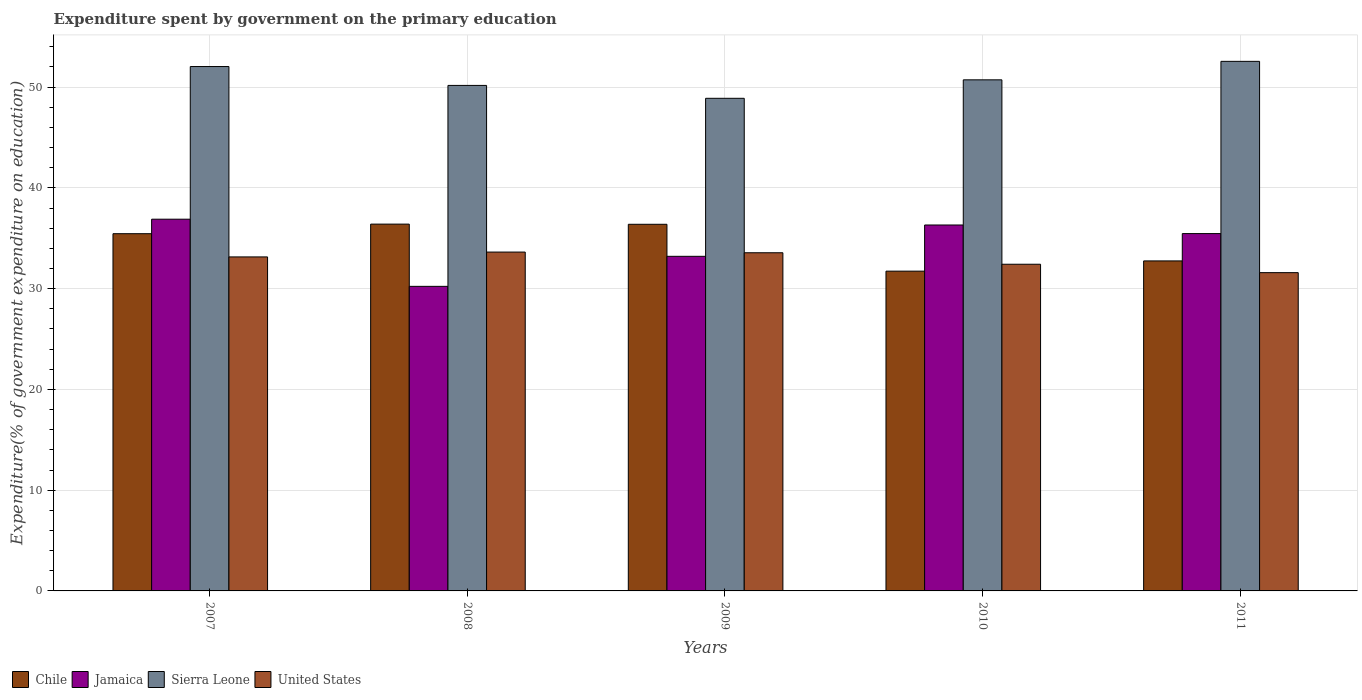Are the number of bars per tick equal to the number of legend labels?
Ensure brevity in your answer.  Yes. What is the label of the 2nd group of bars from the left?
Your response must be concise. 2008. In how many cases, is the number of bars for a given year not equal to the number of legend labels?
Make the answer very short. 0. What is the expenditure spent by government on the primary education in Jamaica in 2008?
Ensure brevity in your answer.  30.23. Across all years, what is the maximum expenditure spent by government on the primary education in Chile?
Make the answer very short. 36.4. Across all years, what is the minimum expenditure spent by government on the primary education in Chile?
Keep it short and to the point. 31.74. In which year was the expenditure spent by government on the primary education in United States maximum?
Provide a short and direct response. 2008. In which year was the expenditure spent by government on the primary education in Jamaica minimum?
Offer a terse response. 2008. What is the total expenditure spent by government on the primary education in Jamaica in the graph?
Make the answer very short. 172.11. What is the difference between the expenditure spent by government on the primary education in Chile in 2008 and that in 2011?
Keep it short and to the point. 3.65. What is the difference between the expenditure spent by government on the primary education in United States in 2011 and the expenditure spent by government on the primary education in Sierra Leone in 2007?
Offer a terse response. -20.46. What is the average expenditure spent by government on the primary education in Sierra Leone per year?
Your answer should be very brief. 50.88. In the year 2007, what is the difference between the expenditure spent by government on the primary education in United States and expenditure spent by government on the primary education in Chile?
Offer a terse response. -2.3. In how many years, is the expenditure spent by government on the primary education in Jamaica greater than 26 %?
Ensure brevity in your answer.  5. What is the ratio of the expenditure spent by government on the primary education in Chile in 2007 to that in 2010?
Make the answer very short. 1.12. What is the difference between the highest and the second highest expenditure spent by government on the primary education in United States?
Provide a succinct answer. 0.07. What is the difference between the highest and the lowest expenditure spent by government on the primary education in Sierra Leone?
Offer a very short reply. 3.67. Is the sum of the expenditure spent by government on the primary education in Sierra Leone in 2007 and 2010 greater than the maximum expenditure spent by government on the primary education in United States across all years?
Provide a short and direct response. Yes. Is it the case that in every year, the sum of the expenditure spent by government on the primary education in Sierra Leone and expenditure spent by government on the primary education in Jamaica is greater than the sum of expenditure spent by government on the primary education in United States and expenditure spent by government on the primary education in Chile?
Provide a succinct answer. Yes. What does the 3rd bar from the left in 2007 represents?
Your answer should be very brief. Sierra Leone. How many bars are there?
Keep it short and to the point. 20. Are all the bars in the graph horizontal?
Ensure brevity in your answer.  No. Are the values on the major ticks of Y-axis written in scientific E-notation?
Your answer should be very brief. No. Does the graph contain any zero values?
Make the answer very short. No. What is the title of the graph?
Ensure brevity in your answer.  Expenditure spent by government on the primary education. What is the label or title of the X-axis?
Offer a very short reply. Years. What is the label or title of the Y-axis?
Give a very brief answer. Expenditure(% of government expenditure on education). What is the Expenditure(% of government expenditure on education) of Chile in 2007?
Offer a terse response. 35.45. What is the Expenditure(% of government expenditure on education) of Jamaica in 2007?
Ensure brevity in your answer.  36.89. What is the Expenditure(% of government expenditure on education) of Sierra Leone in 2007?
Offer a terse response. 52.04. What is the Expenditure(% of government expenditure on education) of United States in 2007?
Offer a very short reply. 33.15. What is the Expenditure(% of government expenditure on education) in Chile in 2008?
Your response must be concise. 36.4. What is the Expenditure(% of government expenditure on education) in Jamaica in 2008?
Provide a succinct answer. 30.23. What is the Expenditure(% of government expenditure on education) in Sierra Leone in 2008?
Your answer should be compact. 50.17. What is the Expenditure(% of government expenditure on education) in United States in 2008?
Keep it short and to the point. 33.63. What is the Expenditure(% of government expenditure on education) in Chile in 2009?
Provide a short and direct response. 36.39. What is the Expenditure(% of government expenditure on education) of Jamaica in 2009?
Offer a very short reply. 33.21. What is the Expenditure(% of government expenditure on education) of Sierra Leone in 2009?
Give a very brief answer. 48.89. What is the Expenditure(% of government expenditure on education) of United States in 2009?
Make the answer very short. 33.56. What is the Expenditure(% of government expenditure on education) in Chile in 2010?
Your response must be concise. 31.74. What is the Expenditure(% of government expenditure on education) in Jamaica in 2010?
Provide a short and direct response. 36.32. What is the Expenditure(% of government expenditure on education) in Sierra Leone in 2010?
Offer a very short reply. 50.72. What is the Expenditure(% of government expenditure on education) in United States in 2010?
Your response must be concise. 32.42. What is the Expenditure(% of government expenditure on education) of Chile in 2011?
Ensure brevity in your answer.  32.75. What is the Expenditure(% of government expenditure on education) in Jamaica in 2011?
Keep it short and to the point. 35.46. What is the Expenditure(% of government expenditure on education) of Sierra Leone in 2011?
Provide a succinct answer. 52.56. What is the Expenditure(% of government expenditure on education) in United States in 2011?
Keep it short and to the point. 31.59. Across all years, what is the maximum Expenditure(% of government expenditure on education) in Chile?
Ensure brevity in your answer.  36.4. Across all years, what is the maximum Expenditure(% of government expenditure on education) in Jamaica?
Offer a very short reply. 36.89. Across all years, what is the maximum Expenditure(% of government expenditure on education) of Sierra Leone?
Provide a short and direct response. 52.56. Across all years, what is the maximum Expenditure(% of government expenditure on education) of United States?
Your answer should be compact. 33.63. Across all years, what is the minimum Expenditure(% of government expenditure on education) in Chile?
Your answer should be compact. 31.74. Across all years, what is the minimum Expenditure(% of government expenditure on education) of Jamaica?
Offer a very short reply. 30.23. Across all years, what is the minimum Expenditure(% of government expenditure on education) in Sierra Leone?
Your answer should be very brief. 48.89. Across all years, what is the minimum Expenditure(% of government expenditure on education) in United States?
Offer a terse response. 31.59. What is the total Expenditure(% of government expenditure on education) in Chile in the graph?
Provide a short and direct response. 172.73. What is the total Expenditure(% of government expenditure on education) in Jamaica in the graph?
Your response must be concise. 172.11. What is the total Expenditure(% of government expenditure on education) in Sierra Leone in the graph?
Keep it short and to the point. 254.38. What is the total Expenditure(% of government expenditure on education) in United States in the graph?
Offer a very short reply. 164.35. What is the difference between the Expenditure(% of government expenditure on education) in Chile in 2007 and that in 2008?
Give a very brief answer. -0.95. What is the difference between the Expenditure(% of government expenditure on education) in Jamaica in 2007 and that in 2008?
Your answer should be compact. 6.67. What is the difference between the Expenditure(% of government expenditure on education) of Sierra Leone in 2007 and that in 2008?
Give a very brief answer. 1.87. What is the difference between the Expenditure(% of government expenditure on education) in United States in 2007 and that in 2008?
Keep it short and to the point. -0.48. What is the difference between the Expenditure(% of government expenditure on education) in Chile in 2007 and that in 2009?
Your answer should be very brief. -0.93. What is the difference between the Expenditure(% of government expenditure on education) of Jamaica in 2007 and that in 2009?
Offer a very short reply. 3.69. What is the difference between the Expenditure(% of government expenditure on education) of Sierra Leone in 2007 and that in 2009?
Your response must be concise. 3.15. What is the difference between the Expenditure(% of government expenditure on education) in United States in 2007 and that in 2009?
Offer a very short reply. -0.41. What is the difference between the Expenditure(% of government expenditure on education) in Chile in 2007 and that in 2010?
Make the answer very short. 3.72. What is the difference between the Expenditure(% of government expenditure on education) in Jamaica in 2007 and that in 2010?
Your response must be concise. 0.58. What is the difference between the Expenditure(% of government expenditure on education) of Sierra Leone in 2007 and that in 2010?
Your answer should be compact. 1.32. What is the difference between the Expenditure(% of government expenditure on education) of United States in 2007 and that in 2010?
Provide a short and direct response. 0.73. What is the difference between the Expenditure(% of government expenditure on education) of Chile in 2007 and that in 2011?
Ensure brevity in your answer.  2.7. What is the difference between the Expenditure(% of government expenditure on education) in Jamaica in 2007 and that in 2011?
Make the answer very short. 1.43. What is the difference between the Expenditure(% of government expenditure on education) in Sierra Leone in 2007 and that in 2011?
Ensure brevity in your answer.  -0.51. What is the difference between the Expenditure(% of government expenditure on education) of United States in 2007 and that in 2011?
Your response must be concise. 1.56. What is the difference between the Expenditure(% of government expenditure on education) in Chile in 2008 and that in 2009?
Keep it short and to the point. 0.02. What is the difference between the Expenditure(% of government expenditure on education) in Jamaica in 2008 and that in 2009?
Give a very brief answer. -2.98. What is the difference between the Expenditure(% of government expenditure on education) in Sierra Leone in 2008 and that in 2009?
Provide a succinct answer. 1.28. What is the difference between the Expenditure(% of government expenditure on education) of United States in 2008 and that in 2009?
Ensure brevity in your answer.  0.07. What is the difference between the Expenditure(% of government expenditure on education) in Chile in 2008 and that in 2010?
Make the answer very short. 4.67. What is the difference between the Expenditure(% of government expenditure on education) of Jamaica in 2008 and that in 2010?
Provide a succinct answer. -6.09. What is the difference between the Expenditure(% of government expenditure on education) in Sierra Leone in 2008 and that in 2010?
Your answer should be compact. -0.55. What is the difference between the Expenditure(% of government expenditure on education) in United States in 2008 and that in 2010?
Offer a terse response. 1.21. What is the difference between the Expenditure(% of government expenditure on education) in Chile in 2008 and that in 2011?
Keep it short and to the point. 3.65. What is the difference between the Expenditure(% of government expenditure on education) of Jamaica in 2008 and that in 2011?
Your answer should be very brief. -5.24. What is the difference between the Expenditure(% of government expenditure on education) in Sierra Leone in 2008 and that in 2011?
Your answer should be compact. -2.39. What is the difference between the Expenditure(% of government expenditure on education) of United States in 2008 and that in 2011?
Your response must be concise. 2.04. What is the difference between the Expenditure(% of government expenditure on education) in Chile in 2009 and that in 2010?
Provide a succinct answer. 4.65. What is the difference between the Expenditure(% of government expenditure on education) in Jamaica in 2009 and that in 2010?
Your response must be concise. -3.11. What is the difference between the Expenditure(% of government expenditure on education) in Sierra Leone in 2009 and that in 2010?
Give a very brief answer. -1.83. What is the difference between the Expenditure(% of government expenditure on education) of United States in 2009 and that in 2010?
Offer a terse response. 1.14. What is the difference between the Expenditure(% of government expenditure on education) of Chile in 2009 and that in 2011?
Make the answer very short. 3.64. What is the difference between the Expenditure(% of government expenditure on education) in Jamaica in 2009 and that in 2011?
Offer a terse response. -2.26. What is the difference between the Expenditure(% of government expenditure on education) of Sierra Leone in 2009 and that in 2011?
Offer a terse response. -3.67. What is the difference between the Expenditure(% of government expenditure on education) of United States in 2009 and that in 2011?
Your response must be concise. 1.97. What is the difference between the Expenditure(% of government expenditure on education) of Chile in 2010 and that in 2011?
Provide a short and direct response. -1.02. What is the difference between the Expenditure(% of government expenditure on education) in Jamaica in 2010 and that in 2011?
Offer a very short reply. 0.85. What is the difference between the Expenditure(% of government expenditure on education) of Sierra Leone in 2010 and that in 2011?
Make the answer very short. -1.83. What is the difference between the Expenditure(% of government expenditure on education) of United States in 2010 and that in 2011?
Keep it short and to the point. 0.83. What is the difference between the Expenditure(% of government expenditure on education) in Chile in 2007 and the Expenditure(% of government expenditure on education) in Jamaica in 2008?
Your response must be concise. 5.23. What is the difference between the Expenditure(% of government expenditure on education) of Chile in 2007 and the Expenditure(% of government expenditure on education) of Sierra Leone in 2008?
Provide a short and direct response. -14.72. What is the difference between the Expenditure(% of government expenditure on education) in Chile in 2007 and the Expenditure(% of government expenditure on education) in United States in 2008?
Your answer should be very brief. 1.82. What is the difference between the Expenditure(% of government expenditure on education) in Jamaica in 2007 and the Expenditure(% of government expenditure on education) in Sierra Leone in 2008?
Give a very brief answer. -13.28. What is the difference between the Expenditure(% of government expenditure on education) in Jamaica in 2007 and the Expenditure(% of government expenditure on education) in United States in 2008?
Provide a succinct answer. 3.26. What is the difference between the Expenditure(% of government expenditure on education) of Sierra Leone in 2007 and the Expenditure(% of government expenditure on education) of United States in 2008?
Offer a terse response. 18.41. What is the difference between the Expenditure(% of government expenditure on education) in Chile in 2007 and the Expenditure(% of government expenditure on education) in Jamaica in 2009?
Your answer should be very brief. 2.25. What is the difference between the Expenditure(% of government expenditure on education) in Chile in 2007 and the Expenditure(% of government expenditure on education) in Sierra Leone in 2009?
Offer a very short reply. -13.44. What is the difference between the Expenditure(% of government expenditure on education) in Chile in 2007 and the Expenditure(% of government expenditure on education) in United States in 2009?
Offer a terse response. 1.89. What is the difference between the Expenditure(% of government expenditure on education) of Jamaica in 2007 and the Expenditure(% of government expenditure on education) of Sierra Leone in 2009?
Offer a terse response. -12. What is the difference between the Expenditure(% of government expenditure on education) in Jamaica in 2007 and the Expenditure(% of government expenditure on education) in United States in 2009?
Offer a very short reply. 3.33. What is the difference between the Expenditure(% of government expenditure on education) in Sierra Leone in 2007 and the Expenditure(% of government expenditure on education) in United States in 2009?
Offer a very short reply. 18.48. What is the difference between the Expenditure(% of government expenditure on education) of Chile in 2007 and the Expenditure(% of government expenditure on education) of Jamaica in 2010?
Give a very brief answer. -0.86. What is the difference between the Expenditure(% of government expenditure on education) in Chile in 2007 and the Expenditure(% of government expenditure on education) in Sierra Leone in 2010?
Make the answer very short. -15.27. What is the difference between the Expenditure(% of government expenditure on education) in Chile in 2007 and the Expenditure(% of government expenditure on education) in United States in 2010?
Give a very brief answer. 3.03. What is the difference between the Expenditure(% of government expenditure on education) of Jamaica in 2007 and the Expenditure(% of government expenditure on education) of Sierra Leone in 2010?
Give a very brief answer. -13.83. What is the difference between the Expenditure(% of government expenditure on education) in Jamaica in 2007 and the Expenditure(% of government expenditure on education) in United States in 2010?
Offer a very short reply. 4.47. What is the difference between the Expenditure(% of government expenditure on education) of Sierra Leone in 2007 and the Expenditure(% of government expenditure on education) of United States in 2010?
Offer a terse response. 19.62. What is the difference between the Expenditure(% of government expenditure on education) of Chile in 2007 and the Expenditure(% of government expenditure on education) of Jamaica in 2011?
Your answer should be compact. -0.01. What is the difference between the Expenditure(% of government expenditure on education) in Chile in 2007 and the Expenditure(% of government expenditure on education) in Sierra Leone in 2011?
Give a very brief answer. -17.1. What is the difference between the Expenditure(% of government expenditure on education) in Chile in 2007 and the Expenditure(% of government expenditure on education) in United States in 2011?
Your answer should be very brief. 3.87. What is the difference between the Expenditure(% of government expenditure on education) in Jamaica in 2007 and the Expenditure(% of government expenditure on education) in Sierra Leone in 2011?
Your answer should be compact. -15.66. What is the difference between the Expenditure(% of government expenditure on education) in Jamaica in 2007 and the Expenditure(% of government expenditure on education) in United States in 2011?
Ensure brevity in your answer.  5.3. What is the difference between the Expenditure(% of government expenditure on education) of Sierra Leone in 2007 and the Expenditure(% of government expenditure on education) of United States in 2011?
Your answer should be very brief. 20.46. What is the difference between the Expenditure(% of government expenditure on education) of Chile in 2008 and the Expenditure(% of government expenditure on education) of Jamaica in 2009?
Your answer should be compact. 3.2. What is the difference between the Expenditure(% of government expenditure on education) in Chile in 2008 and the Expenditure(% of government expenditure on education) in Sierra Leone in 2009?
Your answer should be very brief. -12.49. What is the difference between the Expenditure(% of government expenditure on education) in Chile in 2008 and the Expenditure(% of government expenditure on education) in United States in 2009?
Your answer should be compact. 2.84. What is the difference between the Expenditure(% of government expenditure on education) of Jamaica in 2008 and the Expenditure(% of government expenditure on education) of Sierra Leone in 2009?
Your answer should be compact. -18.66. What is the difference between the Expenditure(% of government expenditure on education) of Jamaica in 2008 and the Expenditure(% of government expenditure on education) of United States in 2009?
Make the answer very short. -3.33. What is the difference between the Expenditure(% of government expenditure on education) of Sierra Leone in 2008 and the Expenditure(% of government expenditure on education) of United States in 2009?
Make the answer very short. 16.61. What is the difference between the Expenditure(% of government expenditure on education) in Chile in 2008 and the Expenditure(% of government expenditure on education) in Jamaica in 2010?
Keep it short and to the point. 0.09. What is the difference between the Expenditure(% of government expenditure on education) of Chile in 2008 and the Expenditure(% of government expenditure on education) of Sierra Leone in 2010?
Give a very brief answer. -14.32. What is the difference between the Expenditure(% of government expenditure on education) in Chile in 2008 and the Expenditure(% of government expenditure on education) in United States in 2010?
Your answer should be very brief. 3.98. What is the difference between the Expenditure(% of government expenditure on education) of Jamaica in 2008 and the Expenditure(% of government expenditure on education) of Sierra Leone in 2010?
Make the answer very short. -20.5. What is the difference between the Expenditure(% of government expenditure on education) in Jamaica in 2008 and the Expenditure(% of government expenditure on education) in United States in 2010?
Offer a terse response. -2.19. What is the difference between the Expenditure(% of government expenditure on education) in Sierra Leone in 2008 and the Expenditure(% of government expenditure on education) in United States in 2010?
Provide a short and direct response. 17.75. What is the difference between the Expenditure(% of government expenditure on education) in Chile in 2008 and the Expenditure(% of government expenditure on education) in Jamaica in 2011?
Offer a terse response. 0.94. What is the difference between the Expenditure(% of government expenditure on education) of Chile in 2008 and the Expenditure(% of government expenditure on education) of Sierra Leone in 2011?
Keep it short and to the point. -16.15. What is the difference between the Expenditure(% of government expenditure on education) in Chile in 2008 and the Expenditure(% of government expenditure on education) in United States in 2011?
Provide a short and direct response. 4.82. What is the difference between the Expenditure(% of government expenditure on education) of Jamaica in 2008 and the Expenditure(% of government expenditure on education) of Sierra Leone in 2011?
Offer a very short reply. -22.33. What is the difference between the Expenditure(% of government expenditure on education) in Jamaica in 2008 and the Expenditure(% of government expenditure on education) in United States in 2011?
Give a very brief answer. -1.36. What is the difference between the Expenditure(% of government expenditure on education) in Sierra Leone in 2008 and the Expenditure(% of government expenditure on education) in United States in 2011?
Make the answer very short. 18.58. What is the difference between the Expenditure(% of government expenditure on education) of Chile in 2009 and the Expenditure(% of government expenditure on education) of Jamaica in 2010?
Provide a short and direct response. 0.07. What is the difference between the Expenditure(% of government expenditure on education) of Chile in 2009 and the Expenditure(% of government expenditure on education) of Sierra Leone in 2010?
Provide a short and direct response. -14.34. What is the difference between the Expenditure(% of government expenditure on education) in Chile in 2009 and the Expenditure(% of government expenditure on education) in United States in 2010?
Provide a succinct answer. 3.97. What is the difference between the Expenditure(% of government expenditure on education) in Jamaica in 2009 and the Expenditure(% of government expenditure on education) in Sierra Leone in 2010?
Provide a short and direct response. -17.52. What is the difference between the Expenditure(% of government expenditure on education) in Jamaica in 2009 and the Expenditure(% of government expenditure on education) in United States in 2010?
Make the answer very short. 0.79. What is the difference between the Expenditure(% of government expenditure on education) in Sierra Leone in 2009 and the Expenditure(% of government expenditure on education) in United States in 2010?
Offer a terse response. 16.47. What is the difference between the Expenditure(% of government expenditure on education) of Chile in 2009 and the Expenditure(% of government expenditure on education) of Jamaica in 2011?
Your response must be concise. 0.92. What is the difference between the Expenditure(% of government expenditure on education) of Chile in 2009 and the Expenditure(% of government expenditure on education) of Sierra Leone in 2011?
Provide a short and direct response. -16.17. What is the difference between the Expenditure(% of government expenditure on education) of Chile in 2009 and the Expenditure(% of government expenditure on education) of United States in 2011?
Your answer should be very brief. 4.8. What is the difference between the Expenditure(% of government expenditure on education) in Jamaica in 2009 and the Expenditure(% of government expenditure on education) in Sierra Leone in 2011?
Keep it short and to the point. -19.35. What is the difference between the Expenditure(% of government expenditure on education) in Jamaica in 2009 and the Expenditure(% of government expenditure on education) in United States in 2011?
Provide a short and direct response. 1.62. What is the difference between the Expenditure(% of government expenditure on education) in Sierra Leone in 2009 and the Expenditure(% of government expenditure on education) in United States in 2011?
Give a very brief answer. 17.3. What is the difference between the Expenditure(% of government expenditure on education) in Chile in 2010 and the Expenditure(% of government expenditure on education) in Jamaica in 2011?
Your answer should be compact. -3.73. What is the difference between the Expenditure(% of government expenditure on education) in Chile in 2010 and the Expenditure(% of government expenditure on education) in Sierra Leone in 2011?
Offer a terse response. -20.82. What is the difference between the Expenditure(% of government expenditure on education) of Chile in 2010 and the Expenditure(% of government expenditure on education) of United States in 2011?
Make the answer very short. 0.15. What is the difference between the Expenditure(% of government expenditure on education) of Jamaica in 2010 and the Expenditure(% of government expenditure on education) of Sierra Leone in 2011?
Your answer should be very brief. -16.24. What is the difference between the Expenditure(% of government expenditure on education) in Jamaica in 2010 and the Expenditure(% of government expenditure on education) in United States in 2011?
Your answer should be compact. 4.73. What is the difference between the Expenditure(% of government expenditure on education) of Sierra Leone in 2010 and the Expenditure(% of government expenditure on education) of United States in 2011?
Keep it short and to the point. 19.14. What is the average Expenditure(% of government expenditure on education) in Chile per year?
Provide a succinct answer. 34.55. What is the average Expenditure(% of government expenditure on education) of Jamaica per year?
Keep it short and to the point. 34.42. What is the average Expenditure(% of government expenditure on education) in Sierra Leone per year?
Give a very brief answer. 50.88. What is the average Expenditure(% of government expenditure on education) of United States per year?
Make the answer very short. 32.87. In the year 2007, what is the difference between the Expenditure(% of government expenditure on education) in Chile and Expenditure(% of government expenditure on education) in Jamaica?
Provide a short and direct response. -1.44. In the year 2007, what is the difference between the Expenditure(% of government expenditure on education) in Chile and Expenditure(% of government expenditure on education) in Sierra Leone?
Offer a very short reply. -16.59. In the year 2007, what is the difference between the Expenditure(% of government expenditure on education) in Chile and Expenditure(% of government expenditure on education) in United States?
Offer a terse response. 2.31. In the year 2007, what is the difference between the Expenditure(% of government expenditure on education) in Jamaica and Expenditure(% of government expenditure on education) in Sierra Leone?
Provide a short and direct response. -15.15. In the year 2007, what is the difference between the Expenditure(% of government expenditure on education) of Jamaica and Expenditure(% of government expenditure on education) of United States?
Give a very brief answer. 3.74. In the year 2007, what is the difference between the Expenditure(% of government expenditure on education) in Sierra Leone and Expenditure(% of government expenditure on education) in United States?
Provide a succinct answer. 18.89. In the year 2008, what is the difference between the Expenditure(% of government expenditure on education) in Chile and Expenditure(% of government expenditure on education) in Jamaica?
Ensure brevity in your answer.  6.18. In the year 2008, what is the difference between the Expenditure(% of government expenditure on education) in Chile and Expenditure(% of government expenditure on education) in Sierra Leone?
Provide a succinct answer. -13.76. In the year 2008, what is the difference between the Expenditure(% of government expenditure on education) of Chile and Expenditure(% of government expenditure on education) of United States?
Give a very brief answer. 2.78. In the year 2008, what is the difference between the Expenditure(% of government expenditure on education) of Jamaica and Expenditure(% of government expenditure on education) of Sierra Leone?
Your response must be concise. -19.94. In the year 2008, what is the difference between the Expenditure(% of government expenditure on education) in Jamaica and Expenditure(% of government expenditure on education) in United States?
Ensure brevity in your answer.  -3.4. In the year 2008, what is the difference between the Expenditure(% of government expenditure on education) in Sierra Leone and Expenditure(% of government expenditure on education) in United States?
Ensure brevity in your answer.  16.54. In the year 2009, what is the difference between the Expenditure(% of government expenditure on education) in Chile and Expenditure(% of government expenditure on education) in Jamaica?
Your answer should be very brief. 3.18. In the year 2009, what is the difference between the Expenditure(% of government expenditure on education) of Chile and Expenditure(% of government expenditure on education) of Sierra Leone?
Ensure brevity in your answer.  -12.5. In the year 2009, what is the difference between the Expenditure(% of government expenditure on education) of Chile and Expenditure(% of government expenditure on education) of United States?
Make the answer very short. 2.83. In the year 2009, what is the difference between the Expenditure(% of government expenditure on education) of Jamaica and Expenditure(% of government expenditure on education) of Sierra Leone?
Your answer should be compact. -15.68. In the year 2009, what is the difference between the Expenditure(% of government expenditure on education) of Jamaica and Expenditure(% of government expenditure on education) of United States?
Your answer should be very brief. -0.35. In the year 2009, what is the difference between the Expenditure(% of government expenditure on education) of Sierra Leone and Expenditure(% of government expenditure on education) of United States?
Give a very brief answer. 15.33. In the year 2010, what is the difference between the Expenditure(% of government expenditure on education) of Chile and Expenditure(% of government expenditure on education) of Jamaica?
Your answer should be very brief. -4.58. In the year 2010, what is the difference between the Expenditure(% of government expenditure on education) of Chile and Expenditure(% of government expenditure on education) of Sierra Leone?
Make the answer very short. -18.99. In the year 2010, what is the difference between the Expenditure(% of government expenditure on education) in Chile and Expenditure(% of government expenditure on education) in United States?
Offer a very short reply. -0.69. In the year 2010, what is the difference between the Expenditure(% of government expenditure on education) of Jamaica and Expenditure(% of government expenditure on education) of Sierra Leone?
Ensure brevity in your answer.  -14.41. In the year 2010, what is the difference between the Expenditure(% of government expenditure on education) of Jamaica and Expenditure(% of government expenditure on education) of United States?
Provide a succinct answer. 3.9. In the year 2010, what is the difference between the Expenditure(% of government expenditure on education) of Sierra Leone and Expenditure(% of government expenditure on education) of United States?
Your answer should be very brief. 18.3. In the year 2011, what is the difference between the Expenditure(% of government expenditure on education) in Chile and Expenditure(% of government expenditure on education) in Jamaica?
Provide a short and direct response. -2.71. In the year 2011, what is the difference between the Expenditure(% of government expenditure on education) in Chile and Expenditure(% of government expenditure on education) in Sierra Leone?
Give a very brief answer. -19.81. In the year 2011, what is the difference between the Expenditure(% of government expenditure on education) of Chile and Expenditure(% of government expenditure on education) of United States?
Make the answer very short. 1.16. In the year 2011, what is the difference between the Expenditure(% of government expenditure on education) in Jamaica and Expenditure(% of government expenditure on education) in Sierra Leone?
Give a very brief answer. -17.09. In the year 2011, what is the difference between the Expenditure(% of government expenditure on education) in Jamaica and Expenditure(% of government expenditure on education) in United States?
Provide a succinct answer. 3.88. In the year 2011, what is the difference between the Expenditure(% of government expenditure on education) in Sierra Leone and Expenditure(% of government expenditure on education) in United States?
Ensure brevity in your answer.  20.97. What is the ratio of the Expenditure(% of government expenditure on education) in Chile in 2007 to that in 2008?
Ensure brevity in your answer.  0.97. What is the ratio of the Expenditure(% of government expenditure on education) in Jamaica in 2007 to that in 2008?
Make the answer very short. 1.22. What is the ratio of the Expenditure(% of government expenditure on education) of Sierra Leone in 2007 to that in 2008?
Offer a terse response. 1.04. What is the ratio of the Expenditure(% of government expenditure on education) in United States in 2007 to that in 2008?
Your answer should be very brief. 0.99. What is the ratio of the Expenditure(% of government expenditure on education) of Chile in 2007 to that in 2009?
Give a very brief answer. 0.97. What is the ratio of the Expenditure(% of government expenditure on education) of Jamaica in 2007 to that in 2009?
Make the answer very short. 1.11. What is the ratio of the Expenditure(% of government expenditure on education) of Sierra Leone in 2007 to that in 2009?
Offer a very short reply. 1.06. What is the ratio of the Expenditure(% of government expenditure on education) in United States in 2007 to that in 2009?
Ensure brevity in your answer.  0.99. What is the ratio of the Expenditure(% of government expenditure on education) in Chile in 2007 to that in 2010?
Your answer should be compact. 1.12. What is the ratio of the Expenditure(% of government expenditure on education) in Jamaica in 2007 to that in 2010?
Your answer should be compact. 1.02. What is the ratio of the Expenditure(% of government expenditure on education) in Sierra Leone in 2007 to that in 2010?
Give a very brief answer. 1.03. What is the ratio of the Expenditure(% of government expenditure on education) in United States in 2007 to that in 2010?
Provide a short and direct response. 1.02. What is the ratio of the Expenditure(% of government expenditure on education) in Chile in 2007 to that in 2011?
Your response must be concise. 1.08. What is the ratio of the Expenditure(% of government expenditure on education) in Jamaica in 2007 to that in 2011?
Your response must be concise. 1.04. What is the ratio of the Expenditure(% of government expenditure on education) in Sierra Leone in 2007 to that in 2011?
Offer a very short reply. 0.99. What is the ratio of the Expenditure(% of government expenditure on education) of United States in 2007 to that in 2011?
Ensure brevity in your answer.  1.05. What is the ratio of the Expenditure(% of government expenditure on education) of Chile in 2008 to that in 2009?
Your response must be concise. 1. What is the ratio of the Expenditure(% of government expenditure on education) in Jamaica in 2008 to that in 2009?
Your answer should be compact. 0.91. What is the ratio of the Expenditure(% of government expenditure on education) in Sierra Leone in 2008 to that in 2009?
Provide a short and direct response. 1.03. What is the ratio of the Expenditure(% of government expenditure on education) of Chile in 2008 to that in 2010?
Keep it short and to the point. 1.15. What is the ratio of the Expenditure(% of government expenditure on education) in Jamaica in 2008 to that in 2010?
Your answer should be very brief. 0.83. What is the ratio of the Expenditure(% of government expenditure on education) in Sierra Leone in 2008 to that in 2010?
Offer a very short reply. 0.99. What is the ratio of the Expenditure(% of government expenditure on education) of United States in 2008 to that in 2010?
Keep it short and to the point. 1.04. What is the ratio of the Expenditure(% of government expenditure on education) in Chile in 2008 to that in 2011?
Provide a short and direct response. 1.11. What is the ratio of the Expenditure(% of government expenditure on education) of Jamaica in 2008 to that in 2011?
Provide a short and direct response. 0.85. What is the ratio of the Expenditure(% of government expenditure on education) in Sierra Leone in 2008 to that in 2011?
Your answer should be compact. 0.95. What is the ratio of the Expenditure(% of government expenditure on education) of United States in 2008 to that in 2011?
Offer a terse response. 1.06. What is the ratio of the Expenditure(% of government expenditure on education) of Chile in 2009 to that in 2010?
Keep it short and to the point. 1.15. What is the ratio of the Expenditure(% of government expenditure on education) in Jamaica in 2009 to that in 2010?
Keep it short and to the point. 0.91. What is the ratio of the Expenditure(% of government expenditure on education) in Sierra Leone in 2009 to that in 2010?
Your response must be concise. 0.96. What is the ratio of the Expenditure(% of government expenditure on education) of United States in 2009 to that in 2010?
Provide a succinct answer. 1.04. What is the ratio of the Expenditure(% of government expenditure on education) in Chile in 2009 to that in 2011?
Offer a very short reply. 1.11. What is the ratio of the Expenditure(% of government expenditure on education) in Jamaica in 2009 to that in 2011?
Your response must be concise. 0.94. What is the ratio of the Expenditure(% of government expenditure on education) of Sierra Leone in 2009 to that in 2011?
Offer a very short reply. 0.93. What is the ratio of the Expenditure(% of government expenditure on education) in United States in 2009 to that in 2011?
Provide a short and direct response. 1.06. What is the ratio of the Expenditure(% of government expenditure on education) of Chile in 2010 to that in 2011?
Offer a very short reply. 0.97. What is the ratio of the Expenditure(% of government expenditure on education) of Jamaica in 2010 to that in 2011?
Offer a very short reply. 1.02. What is the ratio of the Expenditure(% of government expenditure on education) in Sierra Leone in 2010 to that in 2011?
Your answer should be very brief. 0.97. What is the ratio of the Expenditure(% of government expenditure on education) of United States in 2010 to that in 2011?
Your response must be concise. 1.03. What is the difference between the highest and the second highest Expenditure(% of government expenditure on education) in Chile?
Your answer should be compact. 0.02. What is the difference between the highest and the second highest Expenditure(% of government expenditure on education) in Jamaica?
Your answer should be very brief. 0.58. What is the difference between the highest and the second highest Expenditure(% of government expenditure on education) in Sierra Leone?
Offer a terse response. 0.51. What is the difference between the highest and the second highest Expenditure(% of government expenditure on education) in United States?
Keep it short and to the point. 0.07. What is the difference between the highest and the lowest Expenditure(% of government expenditure on education) of Chile?
Your answer should be compact. 4.67. What is the difference between the highest and the lowest Expenditure(% of government expenditure on education) of Jamaica?
Keep it short and to the point. 6.67. What is the difference between the highest and the lowest Expenditure(% of government expenditure on education) in Sierra Leone?
Provide a short and direct response. 3.67. What is the difference between the highest and the lowest Expenditure(% of government expenditure on education) of United States?
Your response must be concise. 2.04. 